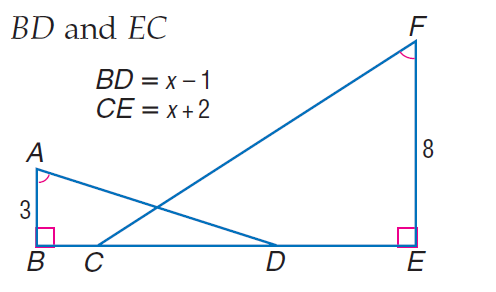Question: Find E C.
Choices:
A. 4.8
B. 5.2
C. 11
D. 12
Answer with the letter. Answer: A Question: Find B D.
Choices:
A. 1.8
B. 2.4
C. 5
D. 6
Answer with the letter. Answer: A 